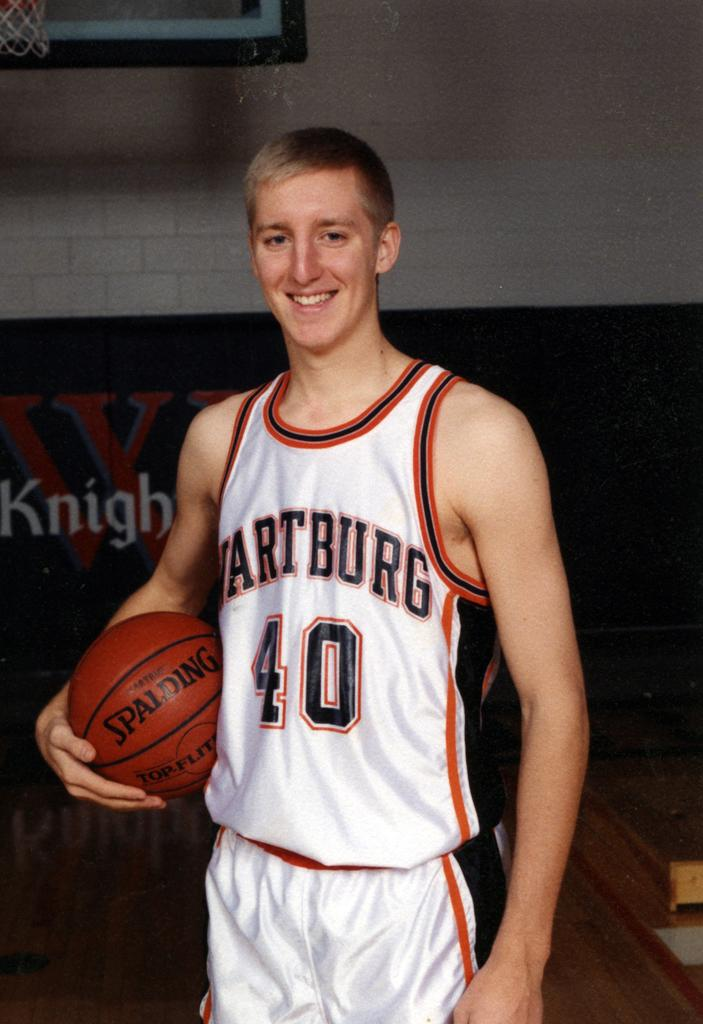<image>
Relay a brief, clear account of the picture shown. A basketball player wearing the jersey number 40 holds a Spalding basketball. 